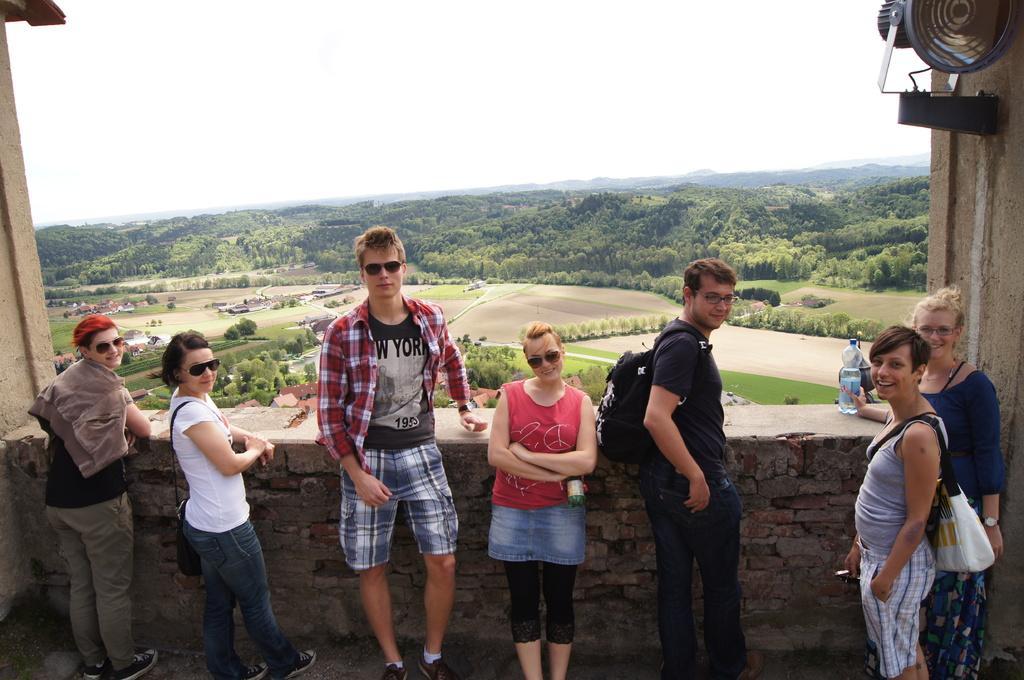Please provide a concise description of this image. In this image, we can see people standing and some are wearing bags and glasses and some are holding some objects. In the background, there is a wall and we can see trees, vehicles on the ground and some sheds. At the top, there is sky. 